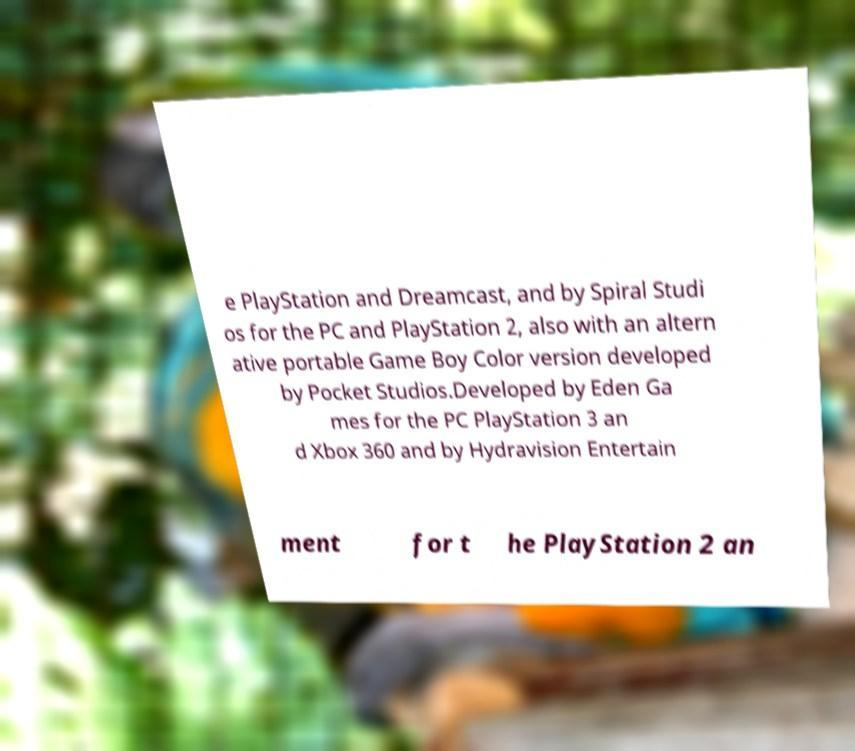Could you extract and type out the text from this image? e PlayStation and Dreamcast, and by Spiral Studi os for the PC and PlayStation 2, also with an altern ative portable Game Boy Color version developed by Pocket Studios.Developed by Eden Ga mes for the PC PlayStation 3 an d Xbox 360 and by Hydravision Entertain ment for t he PlayStation 2 an 